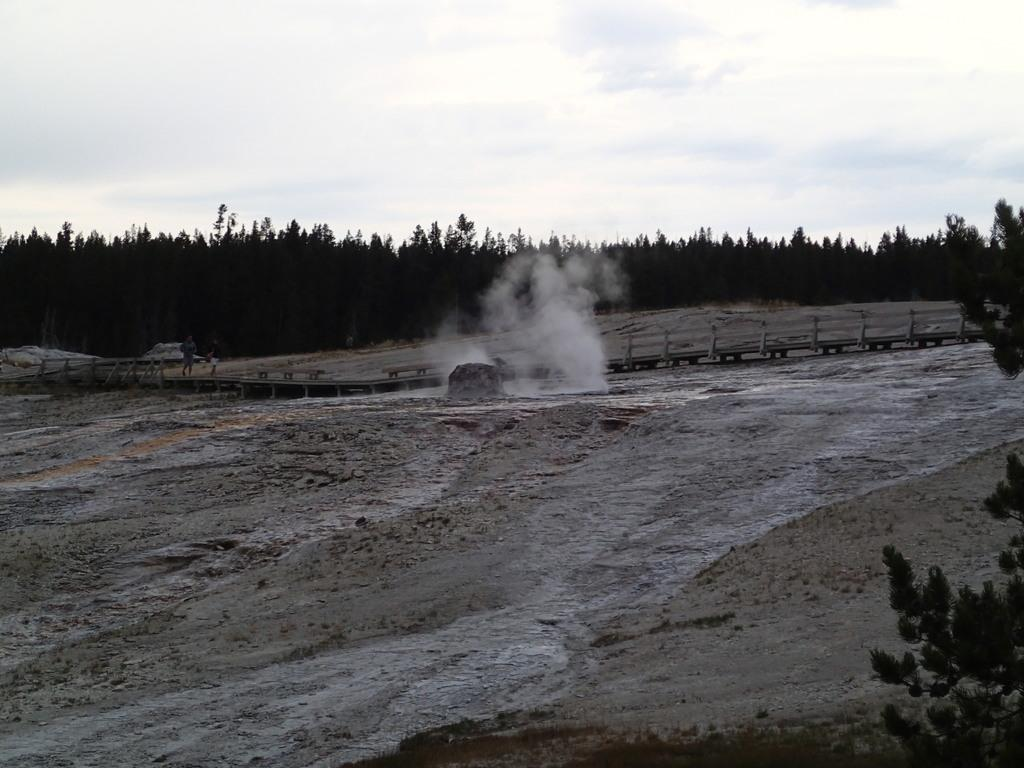What is the color scheme of the image? The image is black and white. What type of natural environment can be seen in the image? There are trees in the image. What are the people in the image doing? The people are on a bridge in the image. What is the source of the smoke visible in the image? The source of the smoke is not specified in the image. What is visible at the top of the image? The sky is visible at the top of the image. What is present at the bottom of the image? There is water and sand at the bottom of the image. How many spoons are being used by the people on the bridge? There are no spoons visible in the image. 